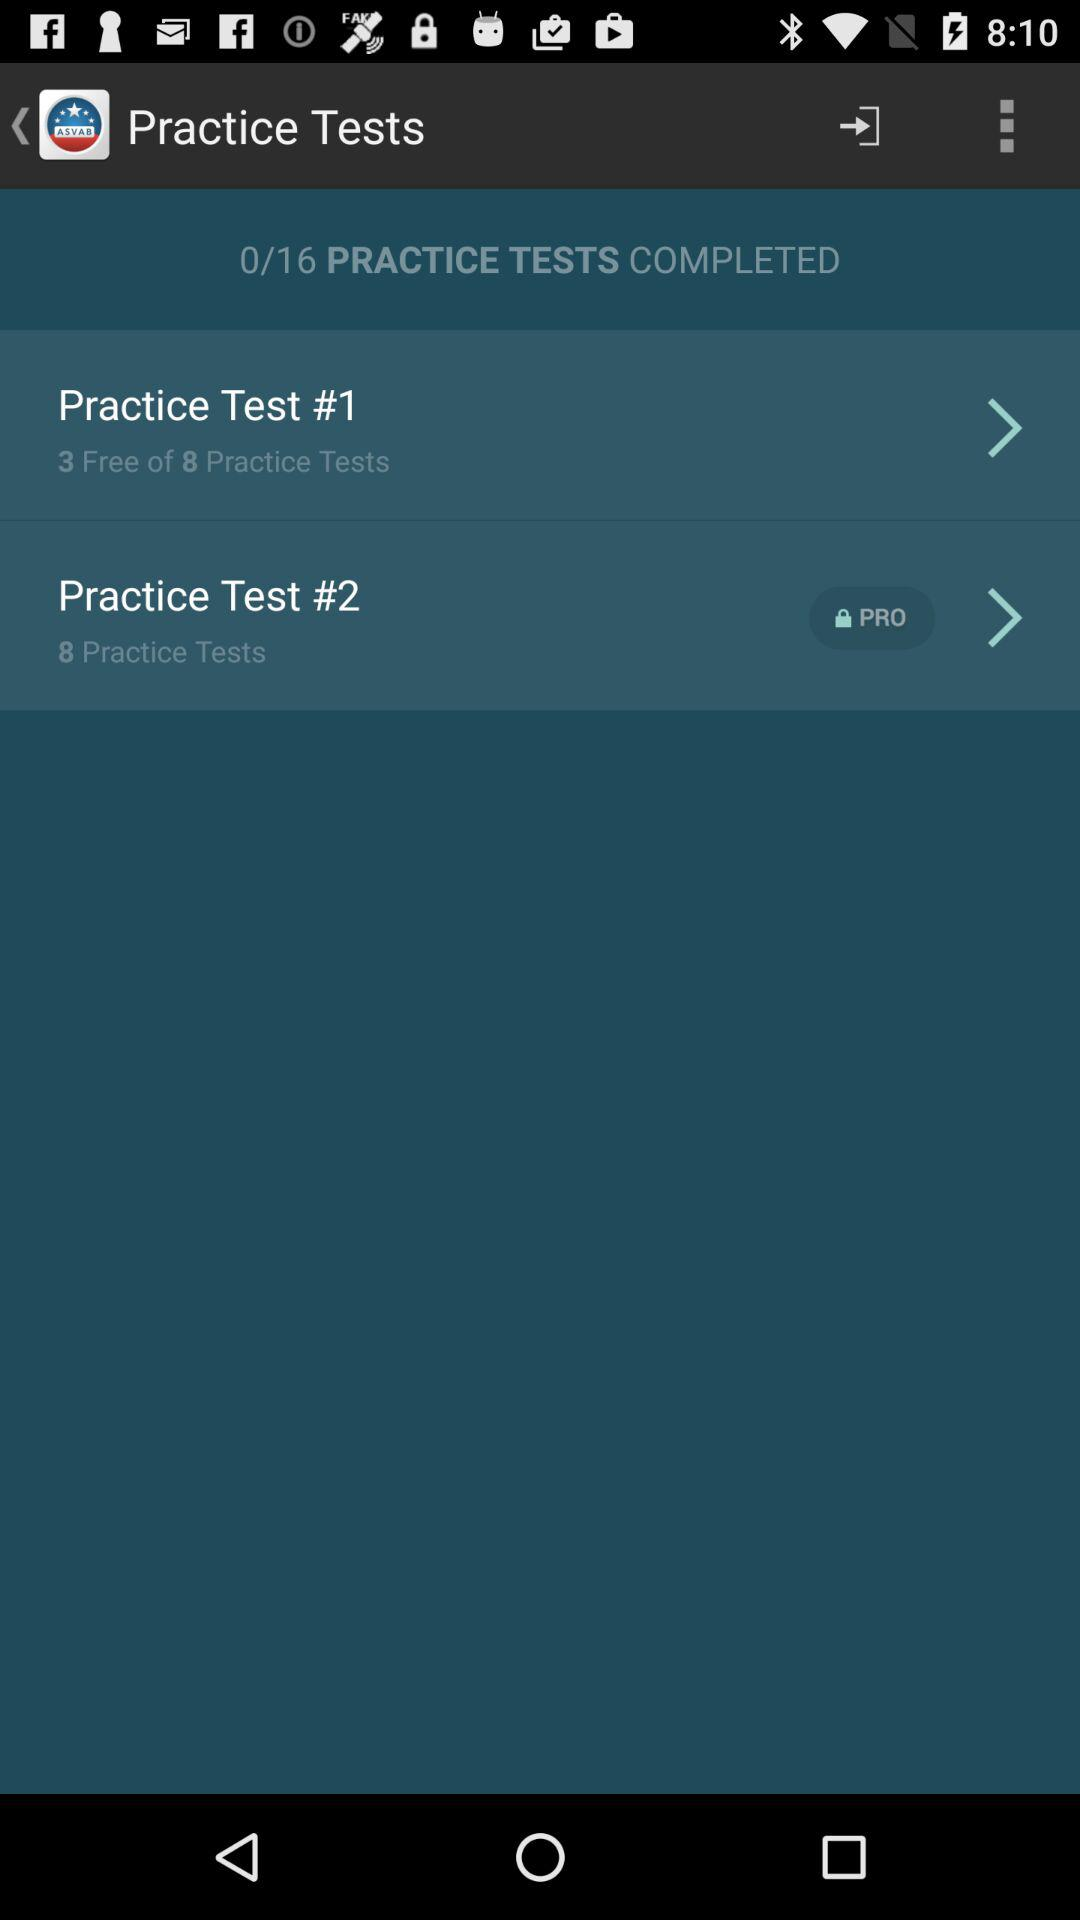How many practice tests are there in total? There are 16 practice tests. 